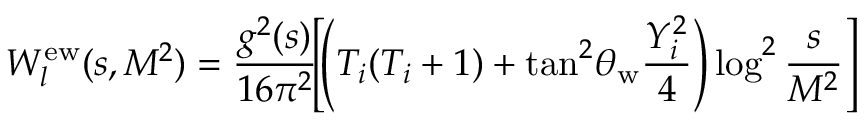Convert formula to latex. <formula><loc_0><loc_0><loc_500><loc_500>W _ { l } ^ { e w } ( s , M ^ { 2 } ) = \frac { g ^ { 2 } ( s ) } { 1 6 \pi ^ { 2 } } \, \left [ \, \left ( T _ { i } ( T _ { i } + 1 ) + \tan ^ { 2 } \, \theta _ { w } \frac { Y _ { i } ^ { 2 } } { 4 } \right ) \log ^ { 2 } \frac { s } { M ^ { 2 } } \right ]</formula> 